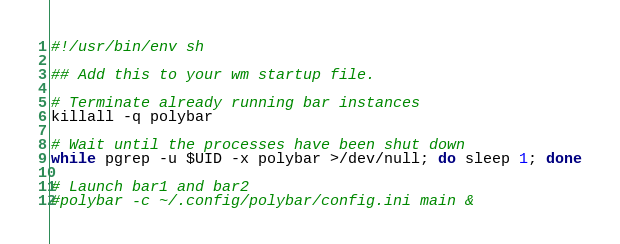Convert code to text. <code><loc_0><loc_0><loc_500><loc_500><_Bash_>#!/usr/bin/env sh

## Add this to your wm startup file.

# Terminate already running bar instances
killall -q polybar

# Wait until the processes have been shut down
while pgrep -u $UID -x polybar >/dev/null; do sleep 1; done

# Launch bar1 and bar2
#polybar -c ~/.config/polybar/config.ini main &
</code> 